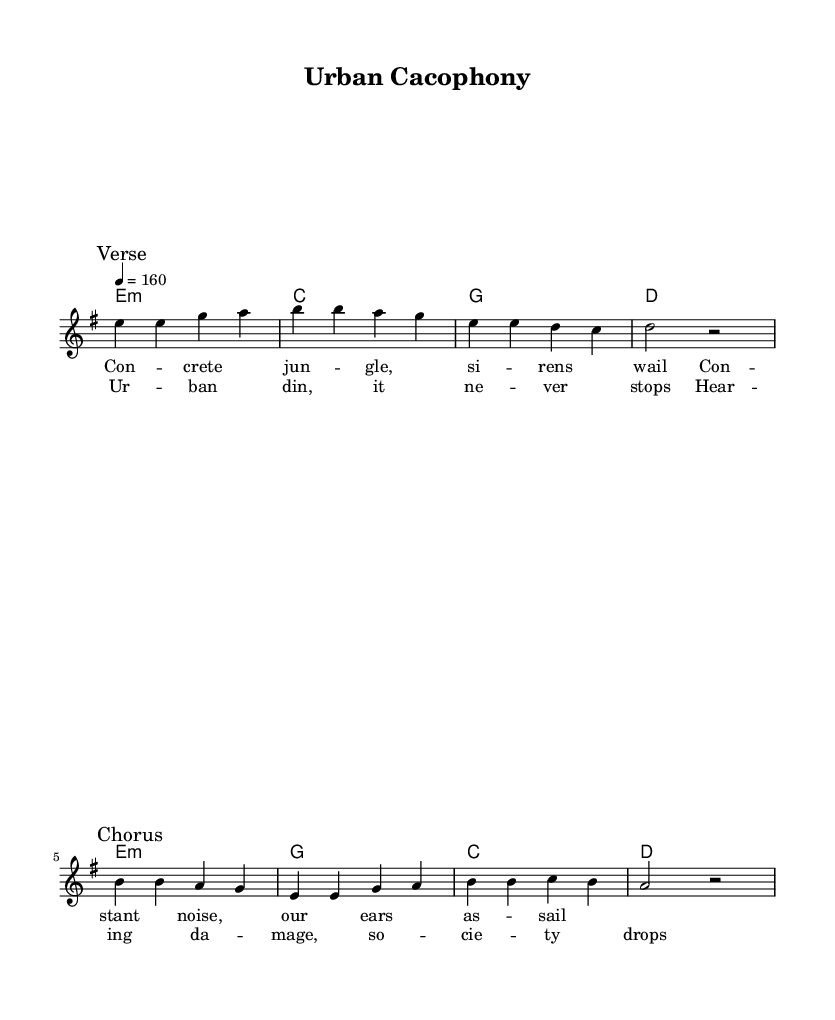What is the key signature of this music? The key signature shows that there are no sharps or flats, which indicates the key of E minor.
Answer: E minor What is the time signature of this music? The time signature is indicated at the beginning of the piece, and it shows there are four beats in each measure, which is represented as 4/4.
Answer: 4/4 What is the tempo marking of this piece? The tempo marking appears in the score and indicates a speed of 160 beats per minute, which is common in punk music for an energetic feel.
Answer: 160 How many measures are in the verse section? The verse section contains four measures: e4 e g a, b b a g, e e d c, and d2 r2. Counting each group of notes and rests shows a total of four.
Answer: 4 What themes do the lyrics of the song address? The lyrics describe the harshness of urban life and the experience of noise pollution by addressing concrete jungles and the constant noise which affects society, emphasizing the message through vivid imagery.
Answer: Noise pollution What is the melodic range of the song? The melody spans from low E to high B, which is the distance from the first note of the piece, e, to the highest note in the chorus, b, demonstrating a one-octave range.
Answer: One octave 